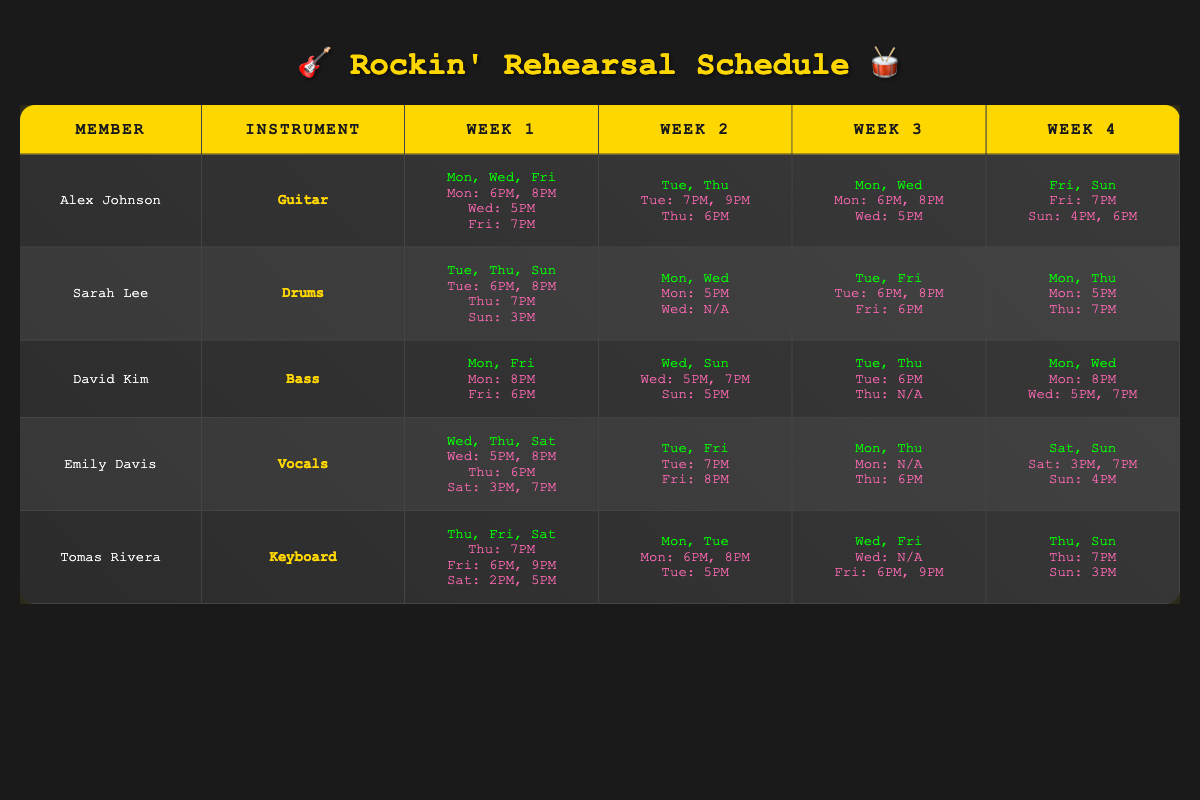What days is Alex Johnson available in week 1? From the table, Alex Johnson is available on Monday, Wednesday, and Friday in week 1.
Answer: Monday, Wednesday, Friday How many members are available on Sunday in week 4? Checking the availability for week 4, only Alex Johnson and Tomas Rivera are available on Sunday. Therefore, there are 2 members available.
Answer: 2 Is Emily Davis available on Friday in week 2? According to the table, Emily is available on Tuesday and Friday in week 2, confirming that she is indeed available on Friday.
Answer: Yes What instrument does Sarah Lee play? By referring to the table, Sarah Lee is associated with the instrument "Drums."
Answer: Drums Which member is available at the latest time in week 1, and what is that time? In week 1, the latest rehearsal time for Alex Johnson is at 8 PM on Monday, and for David Kim, it's 8 PM as well. Hence, the latest time mentioned is 8 PM by both members.
Answer: 8 PM How many different preferred rehearsal times does Tomas Rivera have across all weeks? By reviewing the preferred rehearsal times for Tomas Rivera, he has 6 different times listed: 2 PM, 5 PM, 6 PM, 7 PM, 8 PM, and 9 PM.
Answer: 6 Is there any member available on Wednesday of week 3? The table indicates that both Alex Johnson and David Kim are available on Wednesday in week 3, confirming that yes, there are members available.
Answer: Yes List the rehearsal times available for David Kim on Sundays, across all weeks. David Kim has one rehearsal time on Sunday in week 2 (5 PM) and two in week 4 (5 PM). Summing them gives a total of 3 times across different weeks.
Answer: 3 times What is the total number of instruments represented by the band members? The instruments represented are Guitar, Drums, Bass, Vocals, and Keyboard, totaling 5 distinct instruments.
Answer: 5 Which member has the most available days in week 1? By comparing the availability, all members have different numbers of available days, but Alex Johnson with 3 days (Mon, Wed, Fri) has the most.
Answer: Alex Johnson What is the average number of rehearsal times available for Alex Johnson in week 4? In week 4, Alex has 3 available times (Fri: 7 PM; Sun: 4 PM, 6 PM), thus the average is calculated as 3/1 = 3.
Answer: 3 